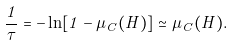<formula> <loc_0><loc_0><loc_500><loc_500>\frac { 1 } { \tau } = - \ln [ 1 - \mu _ { C } ( H ) ] \simeq \mu _ { C } ( H ) .</formula> 